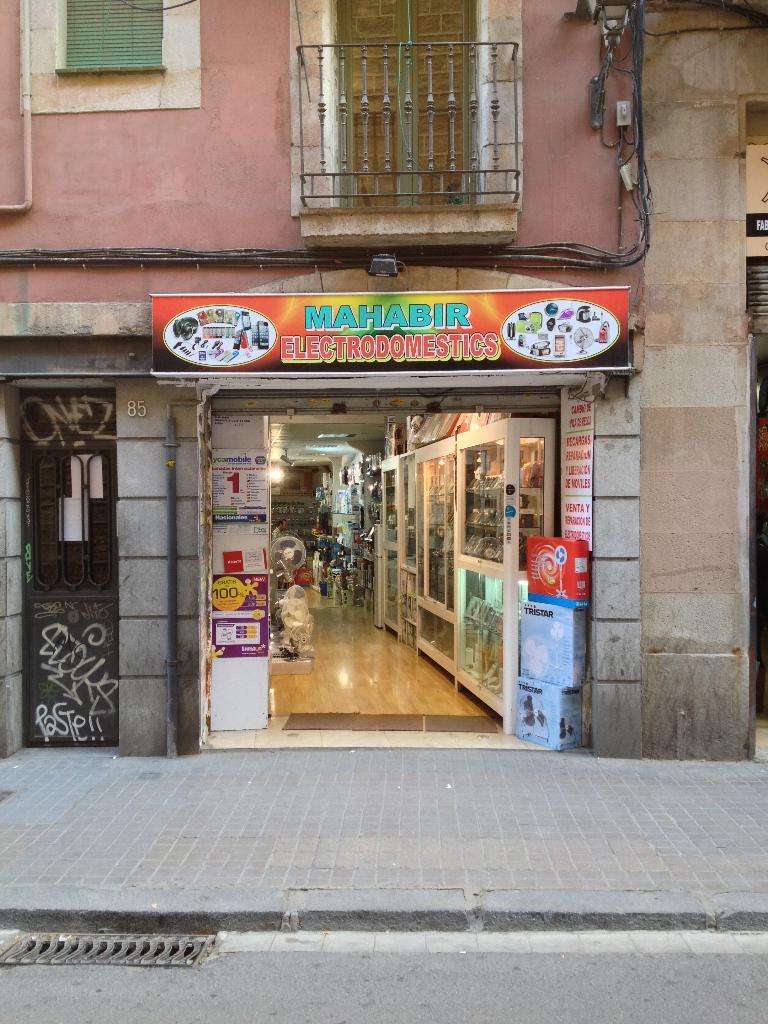What is the name of this store?
Provide a succinct answer. Mahabir. What word is seen in bright blue?
Provide a succinct answer. Mahabir. 